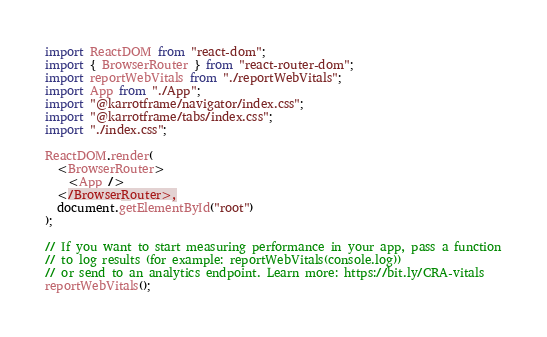<code> <loc_0><loc_0><loc_500><loc_500><_TypeScript_>import ReactDOM from "react-dom";
import { BrowserRouter } from "react-router-dom";
import reportWebVitals from "./reportWebVitals";
import App from "./App";
import "@karrotframe/navigator/index.css";
import "@karrotframe/tabs/index.css";
import "./index.css";

ReactDOM.render(
  <BrowserRouter>
    <App />
  </BrowserRouter>,
  document.getElementById("root")
);

// If you want to start measuring performance in your app, pass a function
// to log results (for example: reportWebVitals(console.log))
// or send to an analytics endpoint. Learn more: https://bit.ly/CRA-vitals
reportWebVitals();
</code> 